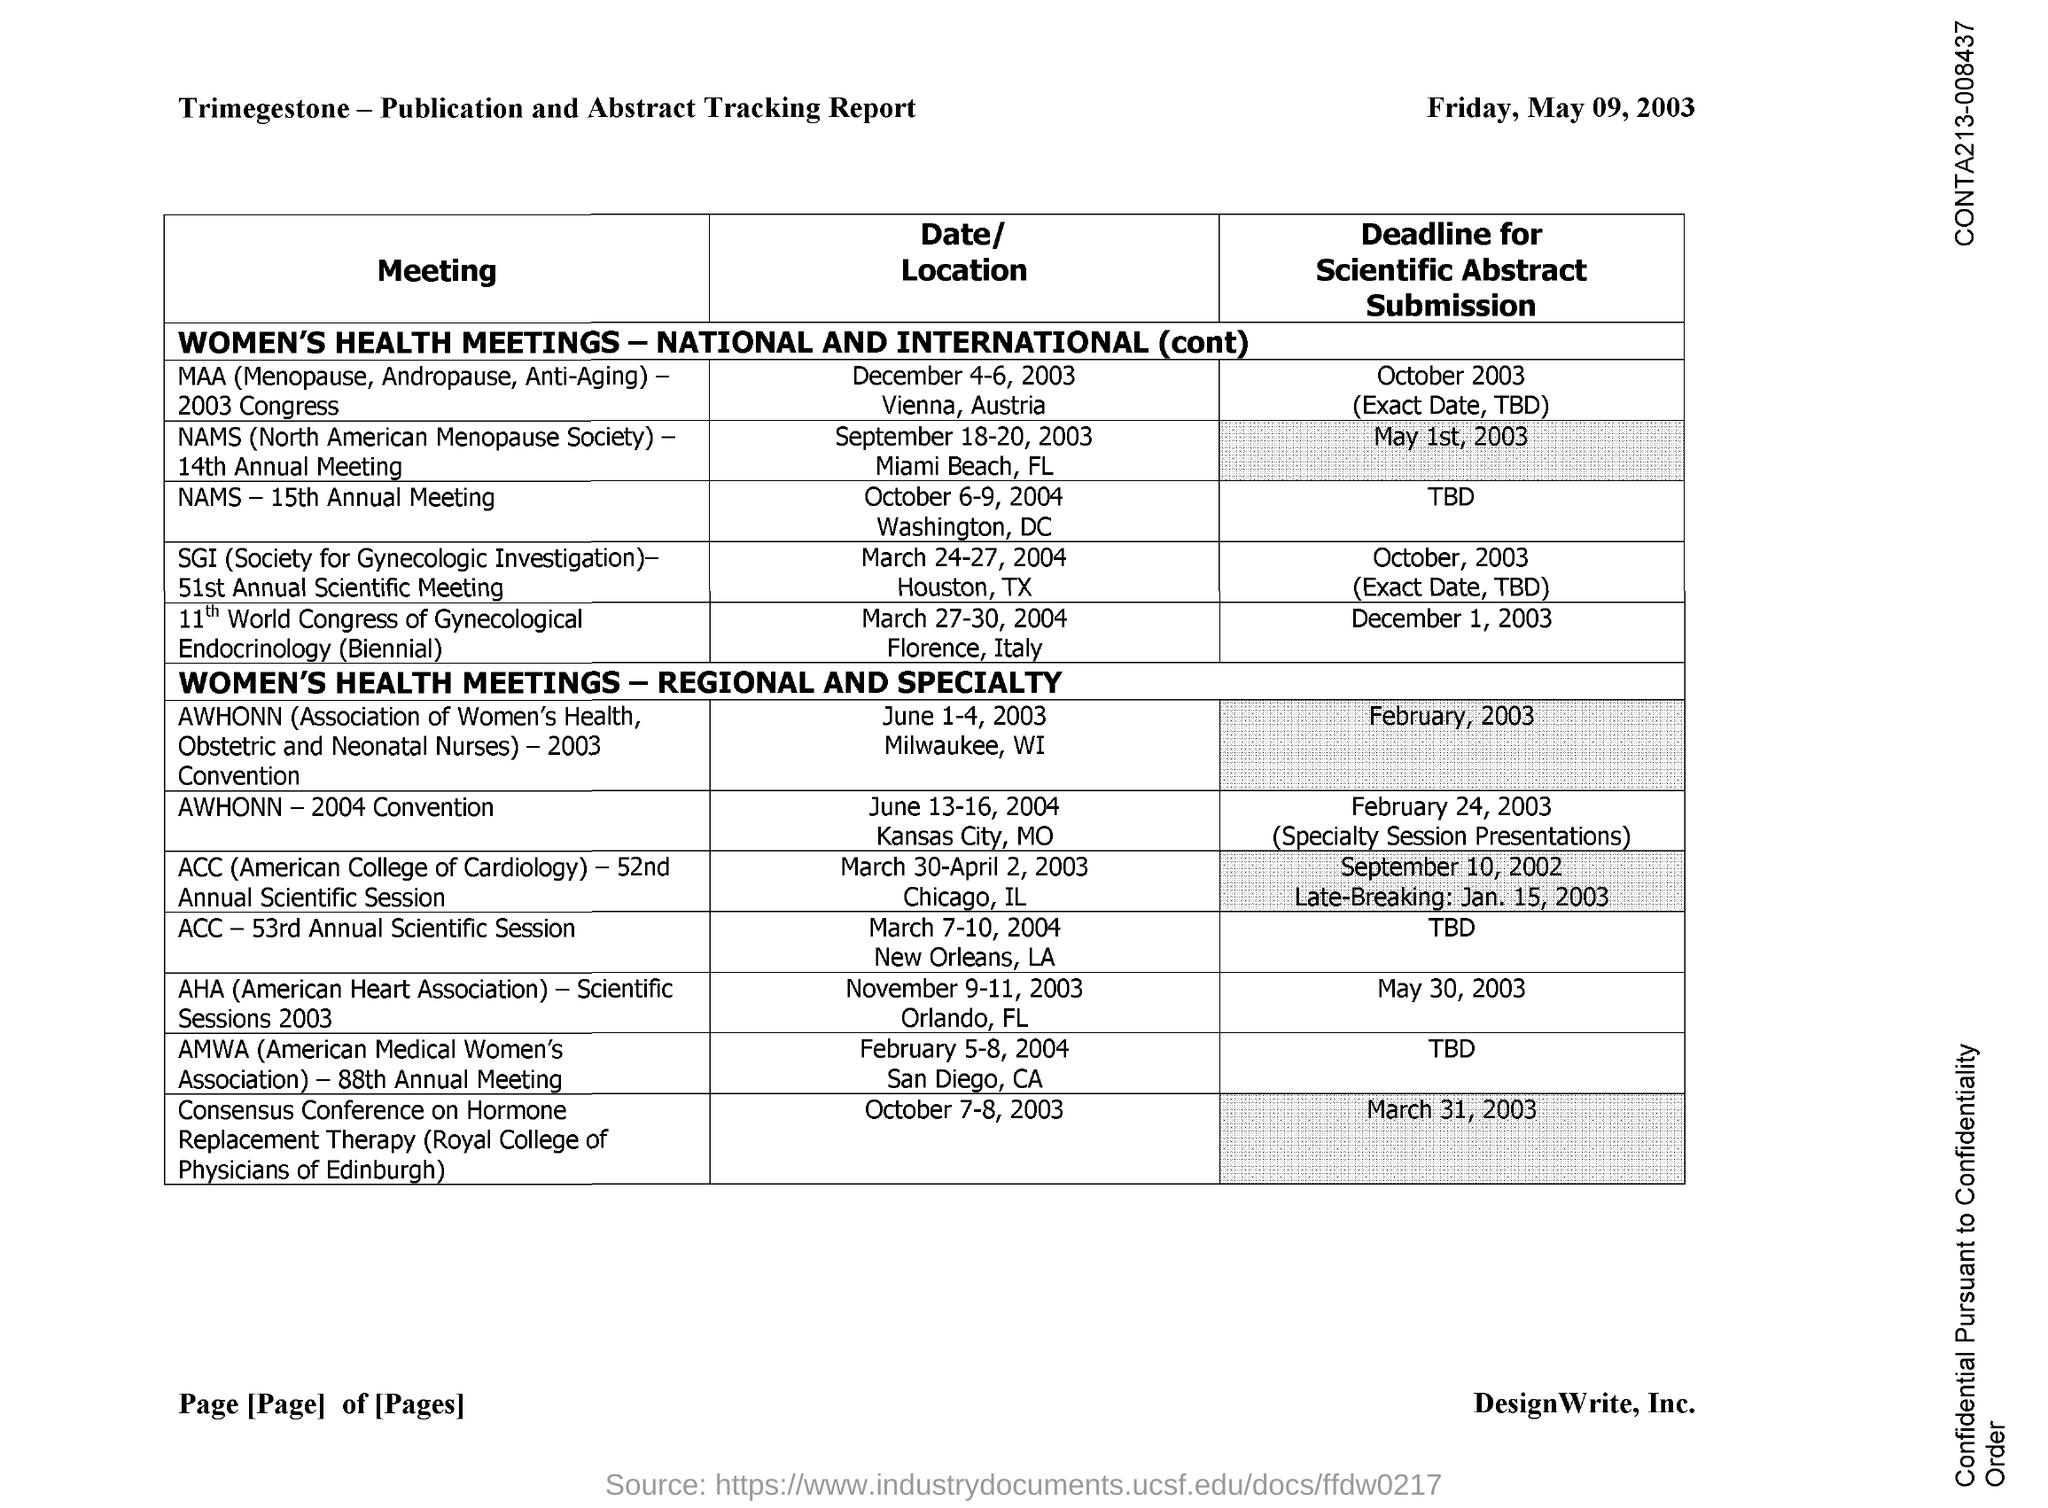What is the full form of AHA?
Provide a short and direct response. American heart association. What is the full form of AMWA?
Ensure brevity in your answer.  American medical women's association. What is the full form of ACC?
Provide a short and direct response. American college of cardiology. 